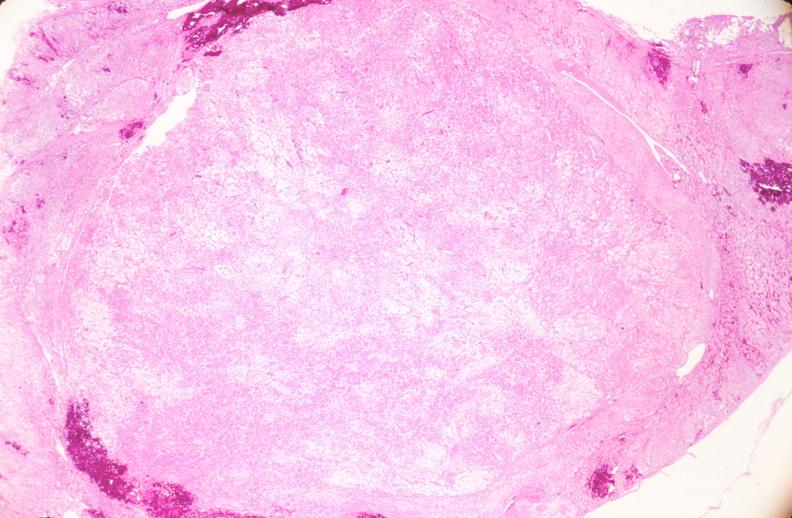s female reproductive present?
Answer the question using a single word or phrase. Yes 